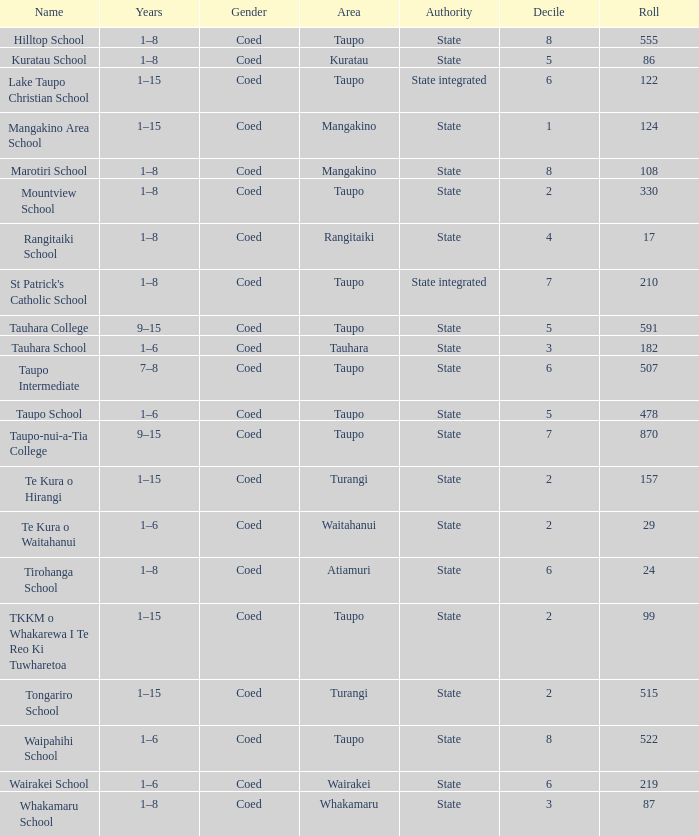What is the whakamaru school's jurisdiction? State. Could you help me parse every detail presented in this table? {'header': ['Name', 'Years', 'Gender', 'Area', 'Authority', 'Decile', 'Roll'], 'rows': [['Hilltop School', '1–8', 'Coed', 'Taupo', 'State', '8', '555'], ['Kuratau School', '1–8', 'Coed', 'Kuratau', 'State', '5', '86'], ['Lake Taupo Christian School', '1–15', 'Coed', 'Taupo', 'State integrated', '6', '122'], ['Mangakino Area School', '1–15', 'Coed', 'Mangakino', 'State', '1', '124'], ['Marotiri School', '1–8', 'Coed', 'Mangakino', 'State', '8', '108'], ['Mountview School', '1–8', 'Coed', 'Taupo', 'State', '2', '330'], ['Rangitaiki School', '1–8', 'Coed', 'Rangitaiki', 'State', '4', '17'], ["St Patrick's Catholic School", '1–8', 'Coed', 'Taupo', 'State integrated', '7', '210'], ['Tauhara College', '9–15', 'Coed', 'Taupo', 'State', '5', '591'], ['Tauhara School', '1–6', 'Coed', 'Tauhara', 'State', '3', '182'], ['Taupo Intermediate', '7–8', 'Coed', 'Taupo', 'State', '6', '507'], ['Taupo School', '1–6', 'Coed', 'Taupo', 'State', '5', '478'], ['Taupo-nui-a-Tia College', '9–15', 'Coed', 'Taupo', 'State', '7', '870'], ['Te Kura o Hirangi', '1–15', 'Coed', 'Turangi', 'State', '2', '157'], ['Te Kura o Waitahanui', '1–6', 'Coed', 'Waitahanui', 'State', '2', '29'], ['Tirohanga School', '1–8', 'Coed', 'Atiamuri', 'State', '6', '24'], ['TKKM o Whakarewa I Te Reo Ki Tuwharetoa', '1–15', 'Coed', 'Taupo', 'State', '2', '99'], ['Tongariro School', '1–15', 'Coed', 'Turangi', 'State', '2', '515'], ['Waipahihi School', '1–6', 'Coed', 'Taupo', 'State', '8', '522'], ['Wairakei School', '1–6', 'Coed', 'Wairakei', 'State', '6', '219'], ['Whakamaru School', '1–8', 'Coed', 'Whakamaru', 'State', '3', '87']]} 